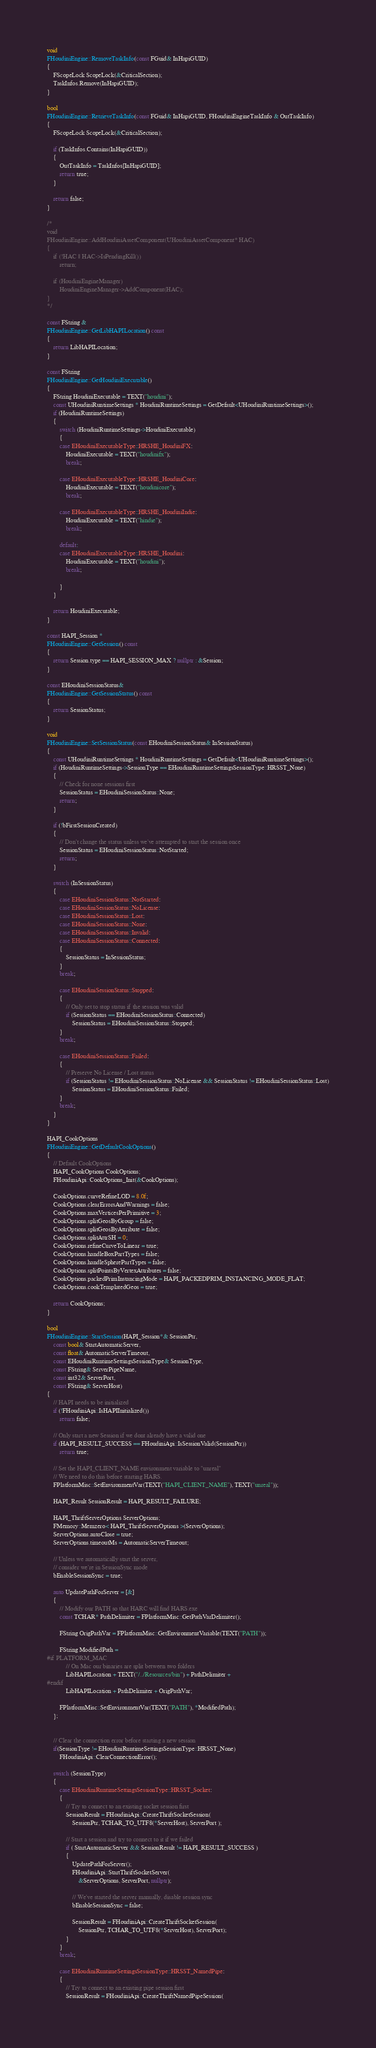<code> <loc_0><loc_0><loc_500><loc_500><_C++_>void
FHoudiniEngine::RemoveTaskInfo(const FGuid& InHapiGUID)
{
	FScopeLock ScopeLock(&CriticalSection);
	TaskInfos.Remove(InHapiGUID);
}

bool
FHoudiniEngine::RetrieveTaskInfo(const FGuid& InHapiGUID, FHoudiniEngineTaskInfo & OutTaskInfo)
{
	FScopeLock ScopeLock(&CriticalSection);

	if (TaskInfos.Contains(InHapiGUID))
	{
		OutTaskInfo = TaskInfos[InHapiGUID];
		return true;
	}

	return false;
}

/*
void
FHoudiniEngine::AddHoudiniAssetComponent(UHoudiniAssetComponent* HAC)
{
	if (!HAC || HAC->IsPendingKill())
		return;

	if (HoudiniEngineManager)
		HoudiniEngineManager->AddComponent(HAC);
}
*/

const FString &
FHoudiniEngine::GetLibHAPILocation() const
{
	return LibHAPILocation;
}

const FString
FHoudiniEngine::GetHoudiniExecutable()
{
	FString HoudiniExecutable = TEXT("houdini");
	const UHoudiniRuntimeSettings * HoudiniRuntimeSettings = GetDefault<UHoudiniRuntimeSettings>();
	if (HoudiniRuntimeSettings)
	{
		switch (HoudiniRuntimeSettings->HoudiniExecutable)
		{
		case EHoudiniExecutableType::HRSHE_HoudiniFX:
			HoudiniExecutable = TEXT("houdinifx");
			break;

		case EHoudiniExecutableType::HRSHE_HoudiniCore:
			HoudiniExecutable = TEXT("houdinicore");
			break;

		case EHoudiniExecutableType::HRSHE_HoudiniIndie:
			HoudiniExecutable = TEXT("hindie");
			break;

		default:
		case EHoudiniExecutableType::HRSHE_Houdini:
			HoudiniExecutable = TEXT("houdini");
			break;

		}
	}

	return HoudiniExecutable;
}

const HAPI_Session *
FHoudiniEngine::GetSession() const
{
	return Session.type == HAPI_SESSION_MAX ? nullptr : &Session;
}

const EHoudiniSessionStatus&
FHoudiniEngine::GetSessionStatus() const
{
	return SessionStatus;
}

void
FHoudiniEngine::SetSessionStatus(const EHoudiniSessionStatus& InSessionStatus)
{
	const UHoudiniRuntimeSettings * HoudiniRuntimeSettings = GetDefault<UHoudiniRuntimeSettings>();
	if (HoudiniRuntimeSettings->SessionType == EHoudiniRuntimeSettingsSessionType::HRSST_None)
	{
		// Check for none sessions first
		SessionStatus = EHoudiniSessionStatus::None;
		return;
	}

	if (!bFirstSessionCreated)
	{
		// Don't change the status unless we've attempted to start the session once
		SessionStatus = EHoudiniSessionStatus::NotStarted;
		return;
	}

	switch (InSessionStatus)
	{
		case EHoudiniSessionStatus::NotStarted:
		case EHoudiniSessionStatus::NoLicense:
		case EHoudiniSessionStatus::Lost:
		case EHoudiniSessionStatus::None:
		case EHoudiniSessionStatus::Invalid:
		case EHoudiniSessionStatus::Connected:
		{
			SessionStatus = InSessionStatus;
		}
		break;

		case EHoudiniSessionStatus::Stopped:
		{
			// Only set to stop status if the session was valid
			if (SessionStatus == EHoudiniSessionStatus::Connected)
				SessionStatus = EHoudiniSessionStatus::Stopped;
		}
		break;

		case EHoudiniSessionStatus::Failed:
		{
			// Preserve No License / Lost status
			if (SessionStatus != EHoudiniSessionStatus::NoLicense && SessionStatus != EHoudiniSessionStatus::Lost)
				SessionStatus = EHoudiniSessionStatus::Failed;
		}
		break;
	}	
}

HAPI_CookOptions
FHoudiniEngine::GetDefaultCookOptions()
{
	// Default CookOptions
	HAPI_CookOptions CookOptions;
	FHoudiniApi::CookOptions_Init(&CookOptions);

	CookOptions.curveRefineLOD = 8.0f;
	CookOptions.clearErrorsAndWarnings = false;
	CookOptions.maxVerticesPerPrimitive = 3;
	CookOptions.splitGeosByGroup = false;
	CookOptions.splitGeosByAttribute = false;
	CookOptions.splitAttrSH = 0;
	CookOptions.refineCurveToLinear = true;
	CookOptions.handleBoxPartTypes = false;
	CookOptions.handleSpherePartTypes = false;
	CookOptions.splitPointsByVertexAttributes = false;
	CookOptions.packedPrimInstancingMode = HAPI_PACKEDPRIM_INSTANCING_MODE_FLAT;
	CookOptions.cookTemplatedGeos = true;

	return CookOptions;
}

bool
FHoudiniEngine::StartSession(HAPI_Session*& SessionPtr,
	const bool& StartAutomaticServer,
	const float& AutomaticServerTimeout,
	const EHoudiniRuntimeSettingsSessionType& SessionType,
	const FString& ServerPipeName,
	const int32& ServerPort,
	const FString& ServerHost)
{
	// HAPI needs to be initialized
	if (!FHoudiniApi::IsHAPIInitialized())
		return false;

	// Only start a new Session if we dont already have a valid one
	if (HAPI_RESULT_SUCCESS == FHoudiniApi::IsSessionValid(SessionPtr))
		return true;

	// Set the HAPI_CLIENT_NAME environment variable to "unreal"
	// We need to do this before starting HARS.
	FPlatformMisc::SetEnvironmentVar(TEXT("HAPI_CLIENT_NAME"), TEXT("unreal"));

	HAPI_Result SessionResult = HAPI_RESULT_FAILURE;

	HAPI_ThriftServerOptions ServerOptions;
	FMemory::Memzero< HAPI_ThriftServerOptions >(ServerOptions);
	ServerOptions.autoClose = true;
	ServerOptions.timeoutMs = AutomaticServerTimeout;

	// Unless we automatically start the server,
	// consider we're in SessionSync mode
	bEnableSessionSync = true;

	auto UpdatePathForServer = [&]
	{
		// Modify our PATH so that HARC will find HARS.exe
		const TCHAR* PathDelimiter = FPlatformMisc::GetPathVarDelimiter();

		FString OrigPathVar = FPlatformMisc::GetEnvironmentVariable(TEXT("PATH"));

		FString ModifiedPath =
#if PLATFORM_MAC
			// On Mac our binaries are split between two folders
			LibHAPILocation + TEXT("/../Resources/bin") + PathDelimiter +
#endif
			LibHAPILocation + PathDelimiter + OrigPathVar;

		FPlatformMisc::SetEnvironmentVar(TEXT("PATH"), *ModifiedPath);
	};


	// Clear the connection error before starting a new session
	if(SessionType != EHoudiniRuntimeSettingsSessionType::HRSST_None)
		FHoudiniApi::ClearConnectionError();

	switch (SessionType)
	{
		case EHoudiniRuntimeSettingsSessionType::HRSST_Socket:
		{
			// Try to connect to an existing socket session first
			SessionResult = FHoudiniApi::CreateThriftSocketSession(
				SessionPtr, TCHAR_TO_UTF8(*ServerHost), ServerPort );

			// Start a session and try to connect to it if we failed
			if ( StartAutomaticServer && SessionResult != HAPI_RESULT_SUCCESS )
			{
				UpdatePathForServer();
				FHoudiniApi::StartThriftSocketServer(
					&ServerOptions, ServerPort, nullptr);

				// We've started the server manually, disable session sync
				bEnableSessionSync = false;

				SessionResult = FHoudiniApi::CreateThriftSocketSession(
					SessionPtr, TCHAR_TO_UTF8(*ServerHost), ServerPort);
			}
		}
		break;

		case EHoudiniRuntimeSettingsSessionType::HRSST_NamedPipe:
		{
			// Try to connect to an existing pipe session first
			SessionResult = FHoudiniApi::CreateThriftNamedPipeSession(</code> 